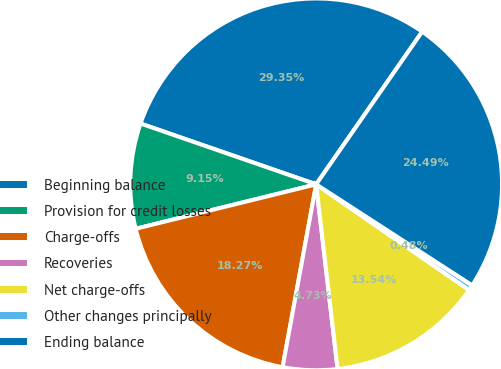Convert chart to OTSL. <chart><loc_0><loc_0><loc_500><loc_500><pie_chart><fcel>Beginning balance<fcel>Provision for credit losses<fcel>Charge-offs<fcel>Recoveries<fcel>Net charge-offs<fcel>Other changes principally<fcel>Ending balance<nl><fcel>29.36%<fcel>9.15%<fcel>18.27%<fcel>4.73%<fcel>13.54%<fcel>0.48%<fcel>24.49%<nl></chart> 